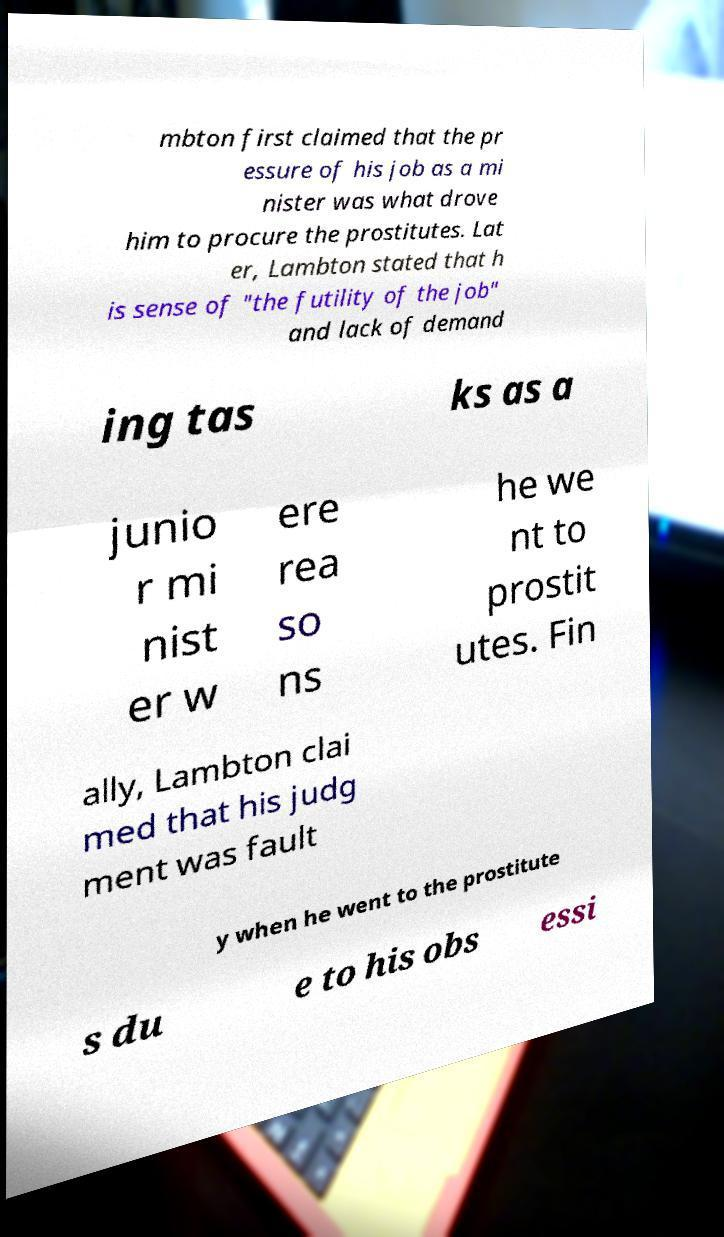Can you accurately transcribe the text from the provided image for me? mbton first claimed that the pr essure of his job as a mi nister was what drove him to procure the prostitutes. Lat er, Lambton stated that h is sense of "the futility of the job" and lack of demand ing tas ks as a junio r mi nist er w ere rea so ns he we nt to prostit utes. Fin ally, Lambton clai med that his judg ment was fault y when he went to the prostitute s du e to his obs essi 